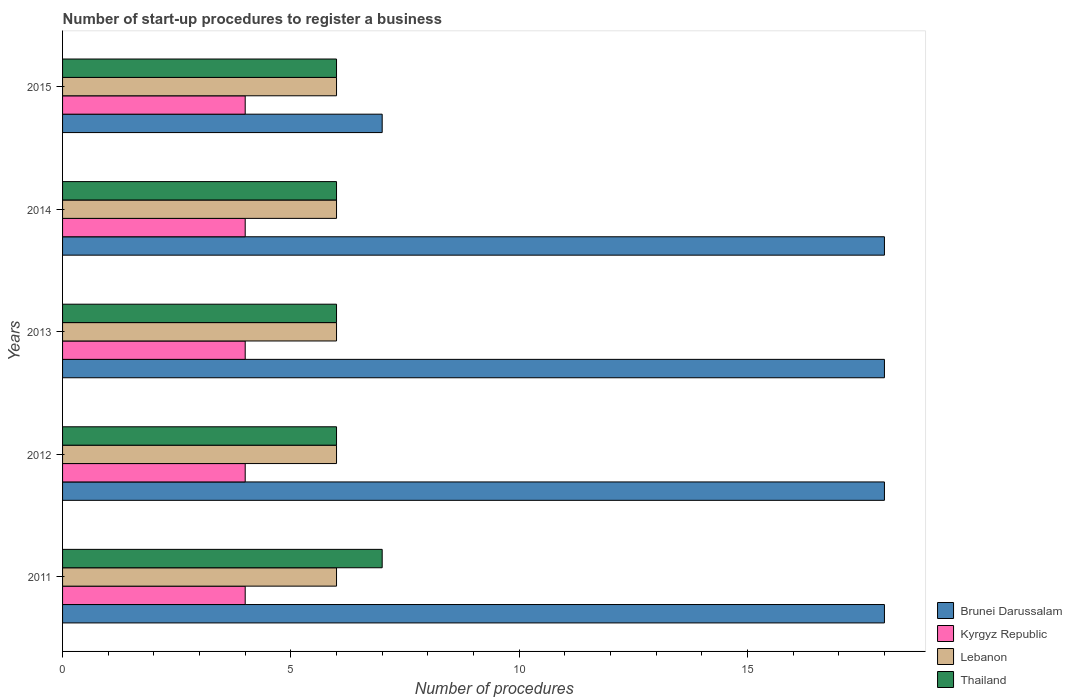How many different coloured bars are there?
Ensure brevity in your answer.  4. How many groups of bars are there?
Give a very brief answer. 5. Are the number of bars per tick equal to the number of legend labels?
Your response must be concise. Yes. Are the number of bars on each tick of the Y-axis equal?
Your answer should be compact. Yes. How many bars are there on the 2nd tick from the bottom?
Keep it short and to the point. 4. What is the label of the 3rd group of bars from the top?
Ensure brevity in your answer.  2013. In how many cases, is the number of bars for a given year not equal to the number of legend labels?
Offer a very short reply. 0. What is the number of procedures required to register a business in Kyrgyz Republic in 2013?
Provide a succinct answer. 4. Across all years, what is the maximum number of procedures required to register a business in Thailand?
Your response must be concise. 7. Across all years, what is the minimum number of procedures required to register a business in Brunei Darussalam?
Offer a very short reply. 7. In which year was the number of procedures required to register a business in Thailand maximum?
Your answer should be compact. 2011. What is the total number of procedures required to register a business in Kyrgyz Republic in the graph?
Your response must be concise. 20. What is the difference between the number of procedures required to register a business in Lebanon in 2014 and the number of procedures required to register a business in Brunei Darussalam in 2013?
Your response must be concise. -12. What is the average number of procedures required to register a business in Lebanon per year?
Your response must be concise. 6. In how many years, is the number of procedures required to register a business in Kyrgyz Republic greater than 17 ?
Your answer should be very brief. 0. Is the number of procedures required to register a business in Brunei Darussalam in 2011 less than that in 2015?
Your answer should be very brief. No. What is the difference between the highest and the second highest number of procedures required to register a business in Lebanon?
Offer a very short reply. 0. What is the difference between the highest and the lowest number of procedures required to register a business in Kyrgyz Republic?
Keep it short and to the point. 0. In how many years, is the number of procedures required to register a business in Kyrgyz Republic greater than the average number of procedures required to register a business in Kyrgyz Republic taken over all years?
Ensure brevity in your answer.  0. Is the sum of the number of procedures required to register a business in Brunei Darussalam in 2011 and 2014 greater than the maximum number of procedures required to register a business in Lebanon across all years?
Make the answer very short. Yes. What does the 3rd bar from the top in 2012 represents?
Offer a very short reply. Kyrgyz Republic. What does the 3rd bar from the bottom in 2012 represents?
Ensure brevity in your answer.  Lebanon. How many bars are there?
Provide a short and direct response. 20. Are all the bars in the graph horizontal?
Offer a very short reply. Yes. How many years are there in the graph?
Make the answer very short. 5. What is the difference between two consecutive major ticks on the X-axis?
Your response must be concise. 5. Are the values on the major ticks of X-axis written in scientific E-notation?
Make the answer very short. No. Does the graph contain any zero values?
Your answer should be compact. No. Does the graph contain grids?
Offer a terse response. No. How many legend labels are there?
Offer a very short reply. 4. What is the title of the graph?
Offer a terse response. Number of start-up procedures to register a business. Does "Netherlands" appear as one of the legend labels in the graph?
Your response must be concise. No. What is the label or title of the X-axis?
Your response must be concise. Number of procedures. What is the label or title of the Y-axis?
Give a very brief answer. Years. What is the Number of procedures of Brunei Darussalam in 2012?
Provide a succinct answer. 18. What is the Number of procedures of Kyrgyz Republic in 2012?
Give a very brief answer. 4. What is the Number of procedures of Kyrgyz Republic in 2013?
Provide a short and direct response. 4. What is the Number of procedures in Kyrgyz Republic in 2015?
Your answer should be very brief. 4. What is the Number of procedures in Lebanon in 2015?
Your answer should be very brief. 6. What is the Number of procedures of Thailand in 2015?
Make the answer very short. 6. Across all years, what is the maximum Number of procedures of Lebanon?
Give a very brief answer. 6. Across all years, what is the minimum Number of procedures in Kyrgyz Republic?
Give a very brief answer. 4. Across all years, what is the minimum Number of procedures in Lebanon?
Give a very brief answer. 6. What is the total Number of procedures of Brunei Darussalam in the graph?
Offer a very short reply. 79. What is the total Number of procedures in Lebanon in the graph?
Make the answer very short. 30. What is the total Number of procedures of Thailand in the graph?
Give a very brief answer. 31. What is the difference between the Number of procedures of Kyrgyz Republic in 2011 and that in 2012?
Your response must be concise. 0. What is the difference between the Number of procedures in Brunei Darussalam in 2011 and that in 2014?
Your answer should be compact. 0. What is the difference between the Number of procedures in Lebanon in 2011 and that in 2014?
Keep it short and to the point. 0. What is the difference between the Number of procedures of Brunei Darussalam in 2011 and that in 2015?
Offer a very short reply. 11. What is the difference between the Number of procedures in Kyrgyz Republic in 2012 and that in 2013?
Offer a terse response. 0. What is the difference between the Number of procedures in Thailand in 2012 and that in 2013?
Your response must be concise. 0. What is the difference between the Number of procedures in Brunei Darussalam in 2012 and that in 2014?
Your answer should be very brief. 0. What is the difference between the Number of procedures of Brunei Darussalam in 2012 and that in 2015?
Provide a short and direct response. 11. What is the difference between the Number of procedures in Lebanon in 2012 and that in 2015?
Provide a succinct answer. 0. What is the difference between the Number of procedures in Thailand in 2012 and that in 2015?
Give a very brief answer. 0. What is the difference between the Number of procedures of Kyrgyz Republic in 2013 and that in 2014?
Ensure brevity in your answer.  0. What is the difference between the Number of procedures in Lebanon in 2013 and that in 2014?
Your answer should be very brief. 0. What is the difference between the Number of procedures of Thailand in 2013 and that in 2014?
Your answer should be very brief. 0. What is the difference between the Number of procedures of Kyrgyz Republic in 2013 and that in 2015?
Your response must be concise. 0. What is the difference between the Number of procedures in Lebanon in 2013 and that in 2015?
Your answer should be compact. 0. What is the difference between the Number of procedures in Thailand in 2013 and that in 2015?
Your answer should be compact. 0. What is the difference between the Number of procedures of Lebanon in 2014 and that in 2015?
Keep it short and to the point. 0. What is the difference between the Number of procedures in Thailand in 2014 and that in 2015?
Make the answer very short. 0. What is the difference between the Number of procedures in Brunei Darussalam in 2011 and the Number of procedures in Kyrgyz Republic in 2012?
Your response must be concise. 14. What is the difference between the Number of procedures in Brunei Darussalam in 2011 and the Number of procedures in Thailand in 2012?
Ensure brevity in your answer.  12. What is the difference between the Number of procedures in Kyrgyz Republic in 2011 and the Number of procedures in Lebanon in 2012?
Your response must be concise. -2. What is the difference between the Number of procedures of Kyrgyz Republic in 2011 and the Number of procedures of Thailand in 2012?
Provide a succinct answer. -2. What is the difference between the Number of procedures in Brunei Darussalam in 2011 and the Number of procedures in Kyrgyz Republic in 2013?
Offer a terse response. 14. What is the difference between the Number of procedures of Brunei Darussalam in 2011 and the Number of procedures of Lebanon in 2013?
Provide a short and direct response. 12. What is the difference between the Number of procedures of Brunei Darussalam in 2011 and the Number of procedures of Thailand in 2013?
Provide a short and direct response. 12. What is the difference between the Number of procedures of Kyrgyz Republic in 2011 and the Number of procedures of Lebanon in 2013?
Offer a very short reply. -2. What is the difference between the Number of procedures of Brunei Darussalam in 2011 and the Number of procedures of Thailand in 2014?
Your answer should be compact. 12. What is the difference between the Number of procedures of Kyrgyz Republic in 2011 and the Number of procedures of Thailand in 2014?
Your answer should be very brief. -2. What is the difference between the Number of procedures of Lebanon in 2011 and the Number of procedures of Thailand in 2014?
Provide a succinct answer. 0. What is the difference between the Number of procedures in Brunei Darussalam in 2011 and the Number of procedures in Thailand in 2015?
Offer a terse response. 12. What is the difference between the Number of procedures of Kyrgyz Republic in 2011 and the Number of procedures of Lebanon in 2015?
Provide a short and direct response. -2. What is the difference between the Number of procedures of Brunei Darussalam in 2012 and the Number of procedures of Kyrgyz Republic in 2013?
Offer a very short reply. 14. What is the difference between the Number of procedures in Brunei Darussalam in 2012 and the Number of procedures in Thailand in 2013?
Ensure brevity in your answer.  12. What is the difference between the Number of procedures of Kyrgyz Republic in 2012 and the Number of procedures of Lebanon in 2013?
Your answer should be compact. -2. What is the difference between the Number of procedures in Kyrgyz Republic in 2012 and the Number of procedures in Thailand in 2013?
Provide a short and direct response. -2. What is the difference between the Number of procedures of Kyrgyz Republic in 2012 and the Number of procedures of Thailand in 2014?
Your answer should be compact. -2. What is the difference between the Number of procedures in Lebanon in 2012 and the Number of procedures in Thailand in 2014?
Offer a very short reply. 0. What is the difference between the Number of procedures of Brunei Darussalam in 2012 and the Number of procedures of Kyrgyz Republic in 2015?
Your answer should be very brief. 14. What is the difference between the Number of procedures of Brunei Darussalam in 2012 and the Number of procedures of Lebanon in 2015?
Offer a very short reply. 12. What is the difference between the Number of procedures in Brunei Darussalam in 2012 and the Number of procedures in Thailand in 2015?
Offer a terse response. 12. What is the difference between the Number of procedures in Kyrgyz Republic in 2012 and the Number of procedures in Lebanon in 2015?
Make the answer very short. -2. What is the difference between the Number of procedures in Kyrgyz Republic in 2012 and the Number of procedures in Thailand in 2015?
Make the answer very short. -2. What is the difference between the Number of procedures in Lebanon in 2012 and the Number of procedures in Thailand in 2015?
Provide a short and direct response. 0. What is the difference between the Number of procedures of Brunei Darussalam in 2013 and the Number of procedures of Lebanon in 2014?
Ensure brevity in your answer.  12. What is the difference between the Number of procedures in Brunei Darussalam in 2013 and the Number of procedures in Thailand in 2014?
Keep it short and to the point. 12. What is the difference between the Number of procedures in Kyrgyz Republic in 2013 and the Number of procedures in Lebanon in 2014?
Provide a short and direct response. -2. What is the difference between the Number of procedures in Kyrgyz Republic in 2013 and the Number of procedures in Thailand in 2014?
Offer a terse response. -2. What is the difference between the Number of procedures of Brunei Darussalam in 2013 and the Number of procedures of Lebanon in 2015?
Your answer should be very brief. 12. What is the difference between the Number of procedures in Brunei Darussalam in 2013 and the Number of procedures in Thailand in 2015?
Your answer should be compact. 12. What is the difference between the Number of procedures of Kyrgyz Republic in 2013 and the Number of procedures of Thailand in 2015?
Ensure brevity in your answer.  -2. What is the difference between the Number of procedures in Brunei Darussalam in 2014 and the Number of procedures in Kyrgyz Republic in 2015?
Ensure brevity in your answer.  14. What is the difference between the Number of procedures of Brunei Darussalam in 2014 and the Number of procedures of Thailand in 2015?
Your answer should be very brief. 12. What is the difference between the Number of procedures of Kyrgyz Republic in 2014 and the Number of procedures of Lebanon in 2015?
Offer a terse response. -2. In the year 2011, what is the difference between the Number of procedures of Brunei Darussalam and Number of procedures of Kyrgyz Republic?
Your answer should be compact. 14. In the year 2012, what is the difference between the Number of procedures of Brunei Darussalam and Number of procedures of Kyrgyz Republic?
Your answer should be compact. 14. In the year 2012, what is the difference between the Number of procedures in Brunei Darussalam and Number of procedures in Thailand?
Keep it short and to the point. 12. In the year 2012, what is the difference between the Number of procedures in Kyrgyz Republic and Number of procedures in Thailand?
Give a very brief answer. -2. In the year 2012, what is the difference between the Number of procedures in Lebanon and Number of procedures in Thailand?
Offer a terse response. 0. In the year 2013, what is the difference between the Number of procedures in Brunei Darussalam and Number of procedures in Kyrgyz Republic?
Your answer should be compact. 14. In the year 2013, what is the difference between the Number of procedures of Brunei Darussalam and Number of procedures of Lebanon?
Your answer should be compact. 12. In the year 2013, what is the difference between the Number of procedures in Brunei Darussalam and Number of procedures in Thailand?
Provide a short and direct response. 12. In the year 2013, what is the difference between the Number of procedures in Kyrgyz Republic and Number of procedures in Thailand?
Keep it short and to the point. -2. In the year 2013, what is the difference between the Number of procedures in Lebanon and Number of procedures in Thailand?
Give a very brief answer. 0. In the year 2014, what is the difference between the Number of procedures of Brunei Darussalam and Number of procedures of Lebanon?
Offer a very short reply. 12. In the year 2014, what is the difference between the Number of procedures of Kyrgyz Republic and Number of procedures of Lebanon?
Give a very brief answer. -2. In the year 2014, what is the difference between the Number of procedures of Lebanon and Number of procedures of Thailand?
Make the answer very short. 0. In the year 2015, what is the difference between the Number of procedures of Brunei Darussalam and Number of procedures of Kyrgyz Republic?
Make the answer very short. 3. In the year 2015, what is the difference between the Number of procedures of Brunei Darussalam and Number of procedures of Lebanon?
Your answer should be very brief. 1. In the year 2015, what is the difference between the Number of procedures of Brunei Darussalam and Number of procedures of Thailand?
Ensure brevity in your answer.  1. What is the ratio of the Number of procedures of Brunei Darussalam in 2011 to that in 2012?
Your answer should be very brief. 1. What is the ratio of the Number of procedures of Kyrgyz Republic in 2011 to that in 2012?
Provide a succinct answer. 1. What is the ratio of the Number of procedures in Lebanon in 2011 to that in 2012?
Make the answer very short. 1. What is the ratio of the Number of procedures in Thailand in 2011 to that in 2012?
Ensure brevity in your answer.  1.17. What is the ratio of the Number of procedures in Brunei Darussalam in 2011 to that in 2013?
Offer a very short reply. 1. What is the ratio of the Number of procedures in Kyrgyz Republic in 2011 to that in 2013?
Provide a succinct answer. 1. What is the ratio of the Number of procedures of Lebanon in 2011 to that in 2013?
Keep it short and to the point. 1. What is the ratio of the Number of procedures of Thailand in 2011 to that in 2013?
Your answer should be compact. 1.17. What is the ratio of the Number of procedures in Brunei Darussalam in 2011 to that in 2014?
Provide a short and direct response. 1. What is the ratio of the Number of procedures of Lebanon in 2011 to that in 2014?
Your response must be concise. 1. What is the ratio of the Number of procedures of Brunei Darussalam in 2011 to that in 2015?
Provide a succinct answer. 2.57. What is the ratio of the Number of procedures of Thailand in 2011 to that in 2015?
Keep it short and to the point. 1.17. What is the ratio of the Number of procedures in Brunei Darussalam in 2012 to that in 2013?
Ensure brevity in your answer.  1. What is the ratio of the Number of procedures of Kyrgyz Republic in 2012 to that in 2013?
Keep it short and to the point. 1. What is the ratio of the Number of procedures in Lebanon in 2012 to that in 2013?
Provide a succinct answer. 1. What is the ratio of the Number of procedures of Kyrgyz Republic in 2012 to that in 2014?
Provide a short and direct response. 1. What is the ratio of the Number of procedures of Brunei Darussalam in 2012 to that in 2015?
Provide a short and direct response. 2.57. What is the ratio of the Number of procedures of Thailand in 2012 to that in 2015?
Give a very brief answer. 1. What is the ratio of the Number of procedures in Brunei Darussalam in 2013 to that in 2014?
Keep it short and to the point. 1. What is the ratio of the Number of procedures in Lebanon in 2013 to that in 2014?
Provide a short and direct response. 1. What is the ratio of the Number of procedures of Brunei Darussalam in 2013 to that in 2015?
Provide a short and direct response. 2.57. What is the ratio of the Number of procedures of Lebanon in 2013 to that in 2015?
Ensure brevity in your answer.  1. What is the ratio of the Number of procedures of Thailand in 2013 to that in 2015?
Provide a succinct answer. 1. What is the ratio of the Number of procedures in Brunei Darussalam in 2014 to that in 2015?
Keep it short and to the point. 2.57. What is the ratio of the Number of procedures of Kyrgyz Republic in 2014 to that in 2015?
Your answer should be very brief. 1. What is the ratio of the Number of procedures of Thailand in 2014 to that in 2015?
Your answer should be compact. 1. What is the difference between the highest and the second highest Number of procedures of Brunei Darussalam?
Make the answer very short. 0. What is the difference between the highest and the second highest Number of procedures in Kyrgyz Republic?
Provide a short and direct response. 0. What is the difference between the highest and the second highest Number of procedures in Lebanon?
Ensure brevity in your answer.  0. What is the difference between the highest and the lowest Number of procedures in Brunei Darussalam?
Ensure brevity in your answer.  11. What is the difference between the highest and the lowest Number of procedures in Lebanon?
Offer a very short reply. 0. What is the difference between the highest and the lowest Number of procedures of Thailand?
Provide a succinct answer. 1. 